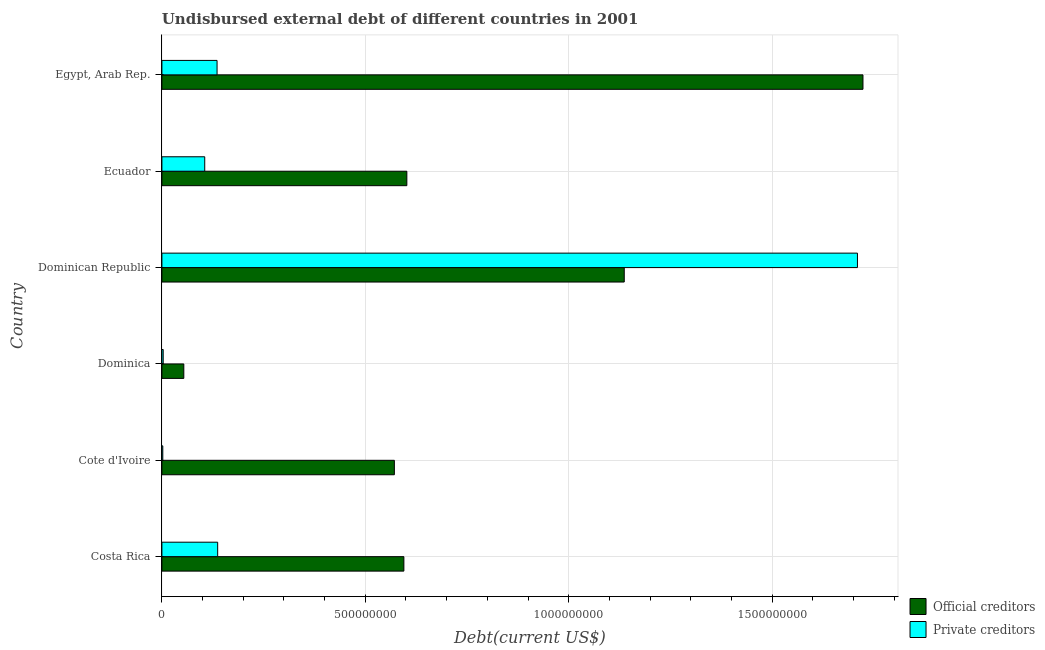Are the number of bars per tick equal to the number of legend labels?
Your answer should be very brief. Yes. Are the number of bars on each tick of the Y-axis equal?
Your answer should be very brief. Yes. How many bars are there on the 3rd tick from the top?
Your response must be concise. 2. How many bars are there on the 4th tick from the bottom?
Offer a very short reply. 2. What is the label of the 2nd group of bars from the top?
Provide a succinct answer. Ecuador. In how many cases, is the number of bars for a given country not equal to the number of legend labels?
Provide a short and direct response. 0. What is the undisbursed external debt of private creditors in Dominican Republic?
Offer a very short reply. 1.71e+09. Across all countries, what is the maximum undisbursed external debt of official creditors?
Your response must be concise. 1.72e+09. Across all countries, what is the minimum undisbursed external debt of official creditors?
Offer a terse response. 5.38e+07. In which country was the undisbursed external debt of private creditors maximum?
Keep it short and to the point. Dominican Republic. In which country was the undisbursed external debt of private creditors minimum?
Your response must be concise. Cote d'Ivoire. What is the total undisbursed external debt of private creditors in the graph?
Provide a short and direct response. 2.09e+09. What is the difference between the undisbursed external debt of private creditors in Cote d'Ivoire and that in Dominica?
Your answer should be very brief. -1.01e+06. What is the difference between the undisbursed external debt of private creditors in Egypt, Arab Rep. and the undisbursed external debt of official creditors in Dominica?
Provide a succinct answer. 8.17e+07. What is the average undisbursed external debt of official creditors per country?
Keep it short and to the point. 7.80e+08. What is the difference between the undisbursed external debt of private creditors and undisbursed external debt of official creditors in Cote d'Ivoire?
Offer a terse response. -5.69e+08. What is the ratio of the undisbursed external debt of private creditors in Costa Rica to that in Cote d'Ivoire?
Your answer should be very brief. 62.47. Is the difference between the undisbursed external debt of private creditors in Costa Rica and Dominican Republic greater than the difference between the undisbursed external debt of official creditors in Costa Rica and Dominican Republic?
Offer a very short reply. No. What is the difference between the highest and the second highest undisbursed external debt of private creditors?
Your response must be concise. 1.57e+09. What is the difference between the highest and the lowest undisbursed external debt of official creditors?
Provide a succinct answer. 1.67e+09. What does the 2nd bar from the top in Egypt, Arab Rep. represents?
Ensure brevity in your answer.  Official creditors. What does the 1st bar from the bottom in Egypt, Arab Rep. represents?
Give a very brief answer. Official creditors. Where does the legend appear in the graph?
Provide a short and direct response. Bottom right. What is the title of the graph?
Offer a very short reply. Undisbursed external debt of different countries in 2001. What is the label or title of the X-axis?
Keep it short and to the point. Debt(current US$). What is the Debt(current US$) in Official creditors in Costa Rica?
Make the answer very short. 5.95e+08. What is the Debt(current US$) in Private creditors in Costa Rica?
Make the answer very short. 1.37e+08. What is the Debt(current US$) in Official creditors in Cote d'Ivoire?
Your answer should be very brief. 5.71e+08. What is the Debt(current US$) in Private creditors in Cote d'Ivoire?
Your response must be concise. 2.20e+06. What is the Debt(current US$) of Official creditors in Dominica?
Ensure brevity in your answer.  5.38e+07. What is the Debt(current US$) of Private creditors in Dominica?
Ensure brevity in your answer.  3.20e+06. What is the Debt(current US$) in Official creditors in Dominican Republic?
Offer a terse response. 1.14e+09. What is the Debt(current US$) in Private creditors in Dominican Republic?
Offer a terse response. 1.71e+09. What is the Debt(current US$) of Official creditors in Ecuador?
Make the answer very short. 6.02e+08. What is the Debt(current US$) of Private creditors in Ecuador?
Keep it short and to the point. 1.05e+08. What is the Debt(current US$) in Official creditors in Egypt, Arab Rep.?
Ensure brevity in your answer.  1.72e+09. What is the Debt(current US$) of Private creditors in Egypt, Arab Rep.?
Your response must be concise. 1.36e+08. Across all countries, what is the maximum Debt(current US$) of Official creditors?
Keep it short and to the point. 1.72e+09. Across all countries, what is the maximum Debt(current US$) in Private creditors?
Give a very brief answer. 1.71e+09. Across all countries, what is the minimum Debt(current US$) of Official creditors?
Make the answer very short. 5.38e+07. Across all countries, what is the minimum Debt(current US$) of Private creditors?
Give a very brief answer. 2.20e+06. What is the total Debt(current US$) of Official creditors in the graph?
Your response must be concise. 4.68e+09. What is the total Debt(current US$) of Private creditors in the graph?
Your answer should be very brief. 2.09e+09. What is the difference between the Debt(current US$) of Official creditors in Costa Rica and that in Cote d'Ivoire?
Give a very brief answer. 2.34e+07. What is the difference between the Debt(current US$) of Private creditors in Costa Rica and that in Cote d'Ivoire?
Ensure brevity in your answer.  1.35e+08. What is the difference between the Debt(current US$) in Official creditors in Costa Rica and that in Dominica?
Keep it short and to the point. 5.41e+08. What is the difference between the Debt(current US$) of Private creditors in Costa Rica and that in Dominica?
Offer a terse response. 1.34e+08. What is the difference between the Debt(current US$) of Official creditors in Costa Rica and that in Dominican Republic?
Ensure brevity in your answer.  -5.42e+08. What is the difference between the Debt(current US$) of Private creditors in Costa Rica and that in Dominican Republic?
Your answer should be compact. -1.57e+09. What is the difference between the Debt(current US$) in Official creditors in Costa Rica and that in Ecuador?
Offer a terse response. -7.28e+06. What is the difference between the Debt(current US$) of Private creditors in Costa Rica and that in Ecuador?
Provide a short and direct response. 3.18e+07. What is the difference between the Debt(current US$) in Official creditors in Costa Rica and that in Egypt, Arab Rep.?
Ensure brevity in your answer.  -1.13e+09. What is the difference between the Debt(current US$) of Private creditors in Costa Rica and that in Egypt, Arab Rep.?
Your answer should be very brief. 1.53e+06. What is the difference between the Debt(current US$) in Official creditors in Cote d'Ivoire and that in Dominica?
Provide a succinct answer. 5.18e+08. What is the difference between the Debt(current US$) of Private creditors in Cote d'Ivoire and that in Dominica?
Offer a very short reply. -1.01e+06. What is the difference between the Debt(current US$) in Official creditors in Cote d'Ivoire and that in Dominican Republic?
Make the answer very short. -5.65e+08. What is the difference between the Debt(current US$) in Private creditors in Cote d'Ivoire and that in Dominican Republic?
Give a very brief answer. -1.71e+09. What is the difference between the Debt(current US$) of Official creditors in Cote d'Ivoire and that in Ecuador?
Your answer should be very brief. -3.07e+07. What is the difference between the Debt(current US$) in Private creditors in Cote d'Ivoire and that in Ecuador?
Ensure brevity in your answer.  -1.03e+08. What is the difference between the Debt(current US$) of Official creditors in Cote d'Ivoire and that in Egypt, Arab Rep.?
Provide a succinct answer. -1.15e+09. What is the difference between the Debt(current US$) of Private creditors in Cote d'Ivoire and that in Egypt, Arab Rep.?
Your answer should be compact. -1.33e+08. What is the difference between the Debt(current US$) of Official creditors in Dominica and that in Dominican Republic?
Your response must be concise. -1.08e+09. What is the difference between the Debt(current US$) in Private creditors in Dominica and that in Dominican Republic?
Your answer should be compact. -1.71e+09. What is the difference between the Debt(current US$) of Official creditors in Dominica and that in Ecuador?
Your answer should be compact. -5.48e+08. What is the difference between the Debt(current US$) in Private creditors in Dominica and that in Ecuador?
Your response must be concise. -1.02e+08. What is the difference between the Debt(current US$) in Official creditors in Dominica and that in Egypt, Arab Rep.?
Provide a short and direct response. -1.67e+09. What is the difference between the Debt(current US$) of Private creditors in Dominica and that in Egypt, Arab Rep.?
Your answer should be compact. -1.32e+08. What is the difference between the Debt(current US$) in Official creditors in Dominican Republic and that in Ecuador?
Your answer should be compact. 5.34e+08. What is the difference between the Debt(current US$) of Private creditors in Dominican Republic and that in Ecuador?
Your response must be concise. 1.60e+09. What is the difference between the Debt(current US$) in Official creditors in Dominican Republic and that in Egypt, Arab Rep.?
Your answer should be very brief. -5.87e+08. What is the difference between the Debt(current US$) of Private creditors in Dominican Republic and that in Egypt, Arab Rep.?
Keep it short and to the point. 1.57e+09. What is the difference between the Debt(current US$) in Official creditors in Ecuador and that in Egypt, Arab Rep.?
Your answer should be compact. -1.12e+09. What is the difference between the Debt(current US$) of Private creditors in Ecuador and that in Egypt, Arab Rep.?
Your answer should be compact. -3.03e+07. What is the difference between the Debt(current US$) of Official creditors in Costa Rica and the Debt(current US$) of Private creditors in Cote d'Ivoire?
Keep it short and to the point. 5.93e+08. What is the difference between the Debt(current US$) of Official creditors in Costa Rica and the Debt(current US$) of Private creditors in Dominica?
Provide a short and direct response. 5.92e+08. What is the difference between the Debt(current US$) in Official creditors in Costa Rica and the Debt(current US$) in Private creditors in Dominican Republic?
Make the answer very short. -1.11e+09. What is the difference between the Debt(current US$) of Official creditors in Costa Rica and the Debt(current US$) of Private creditors in Ecuador?
Offer a terse response. 4.90e+08. What is the difference between the Debt(current US$) of Official creditors in Costa Rica and the Debt(current US$) of Private creditors in Egypt, Arab Rep.?
Keep it short and to the point. 4.59e+08. What is the difference between the Debt(current US$) of Official creditors in Cote d'Ivoire and the Debt(current US$) of Private creditors in Dominica?
Make the answer very short. 5.68e+08. What is the difference between the Debt(current US$) of Official creditors in Cote d'Ivoire and the Debt(current US$) of Private creditors in Dominican Republic?
Your answer should be very brief. -1.14e+09. What is the difference between the Debt(current US$) in Official creditors in Cote d'Ivoire and the Debt(current US$) in Private creditors in Ecuador?
Your answer should be very brief. 4.66e+08. What is the difference between the Debt(current US$) in Official creditors in Cote d'Ivoire and the Debt(current US$) in Private creditors in Egypt, Arab Rep.?
Keep it short and to the point. 4.36e+08. What is the difference between the Debt(current US$) in Official creditors in Dominica and the Debt(current US$) in Private creditors in Dominican Republic?
Provide a short and direct response. -1.66e+09. What is the difference between the Debt(current US$) in Official creditors in Dominica and the Debt(current US$) in Private creditors in Ecuador?
Make the answer very short. -5.15e+07. What is the difference between the Debt(current US$) in Official creditors in Dominica and the Debt(current US$) in Private creditors in Egypt, Arab Rep.?
Offer a very short reply. -8.17e+07. What is the difference between the Debt(current US$) in Official creditors in Dominican Republic and the Debt(current US$) in Private creditors in Ecuador?
Your response must be concise. 1.03e+09. What is the difference between the Debt(current US$) in Official creditors in Dominican Republic and the Debt(current US$) in Private creditors in Egypt, Arab Rep.?
Give a very brief answer. 1.00e+09. What is the difference between the Debt(current US$) of Official creditors in Ecuador and the Debt(current US$) of Private creditors in Egypt, Arab Rep.?
Make the answer very short. 4.67e+08. What is the average Debt(current US$) in Official creditors per country?
Offer a terse response. 7.80e+08. What is the average Debt(current US$) in Private creditors per country?
Give a very brief answer. 3.49e+08. What is the difference between the Debt(current US$) of Official creditors and Debt(current US$) of Private creditors in Costa Rica?
Offer a terse response. 4.58e+08. What is the difference between the Debt(current US$) in Official creditors and Debt(current US$) in Private creditors in Cote d'Ivoire?
Make the answer very short. 5.69e+08. What is the difference between the Debt(current US$) in Official creditors and Debt(current US$) in Private creditors in Dominica?
Ensure brevity in your answer.  5.06e+07. What is the difference between the Debt(current US$) of Official creditors and Debt(current US$) of Private creditors in Dominican Republic?
Your answer should be very brief. -5.73e+08. What is the difference between the Debt(current US$) in Official creditors and Debt(current US$) in Private creditors in Ecuador?
Provide a short and direct response. 4.97e+08. What is the difference between the Debt(current US$) of Official creditors and Debt(current US$) of Private creditors in Egypt, Arab Rep.?
Ensure brevity in your answer.  1.59e+09. What is the ratio of the Debt(current US$) of Official creditors in Costa Rica to that in Cote d'Ivoire?
Offer a terse response. 1.04. What is the ratio of the Debt(current US$) of Private creditors in Costa Rica to that in Cote d'Ivoire?
Provide a succinct answer. 62.47. What is the ratio of the Debt(current US$) in Official creditors in Costa Rica to that in Dominica?
Make the answer very short. 11.05. What is the ratio of the Debt(current US$) in Private creditors in Costa Rica to that in Dominica?
Your response must be concise. 42.78. What is the ratio of the Debt(current US$) in Official creditors in Costa Rica to that in Dominican Republic?
Give a very brief answer. 0.52. What is the ratio of the Debt(current US$) in Private creditors in Costa Rica to that in Dominican Republic?
Make the answer very short. 0.08. What is the ratio of the Debt(current US$) in Official creditors in Costa Rica to that in Ecuador?
Keep it short and to the point. 0.99. What is the ratio of the Debt(current US$) in Private creditors in Costa Rica to that in Ecuador?
Your answer should be very brief. 1.3. What is the ratio of the Debt(current US$) in Official creditors in Costa Rica to that in Egypt, Arab Rep.?
Ensure brevity in your answer.  0.35. What is the ratio of the Debt(current US$) in Private creditors in Costa Rica to that in Egypt, Arab Rep.?
Offer a very short reply. 1.01. What is the ratio of the Debt(current US$) of Official creditors in Cote d'Ivoire to that in Dominica?
Keep it short and to the point. 10.61. What is the ratio of the Debt(current US$) of Private creditors in Cote d'Ivoire to that in Dominica?
Your answer should be compact. 0.68. What is the ratio of the Debt(current US$) of Official creditors in Cote d'Ivoire to that in Dominican Republic?
Offer a very short reply. 0.5. What is the ratio of the Debt(current US$) of Private creditors in Cote d'Ivoire to that in Dominican Republic?
Make the answer very short. 0. What is the ratio of the Debt(current US$) of Official creditors in Cote d'Ivoire to that in Ecuador?
Provide a short and direct response. 0.95. What is the ratio of the Debt(current US$) of Private creditors in Cote d'Ivoire to that in Ecuador?
Make the answer very short. 0.02. What is the ratio of the Debt(current US$) of Official creditors in Cote d'Ivoire to that in Egypt, Arab Rep.?
Offer a very short reply. 0.33. What is the ratio of the Debt(current US$) of Private creditors in Cote d'Ivoire to that in Egypt, Arab Rep.?
Your response must be concise. 0.02. What is the ratio of the Debt(current US$) of Official creditors in Dominica to that in Dominican Republic?
Make the answer very short. 0.05. What is the ratio of the Debt(current US$) of Private creditors in Dominica to that in Dominican Republic?
Your answer should be compact. 0. What is the ratio of the Debt(current US$) in Official creditors in Dominica to that in Ecuador?
Your answer should be compact. 0.09. What is the ratio of the Debt(current US$) of Private creditors in Dominica to that in Ecuador?
Ensure brevity in your answer.  0.03. What is the ratio of the Debt(current US$) of Official creditors in Dominica to that in Egypt, Arab Rep.?
Provide a short and direct response. 0.03. What is the ratio of the Debt(current US$) of Private creditors in Dominica to that in Egypt, Arab Rep.?
Your response must be concise. 0.02. What is the ratio of the Debt(current US$) of Official creditors in Dominican Republic to that in Ecuador?
Offer a very short reply. 1.89. What is the ratio of the Debt(current US$) in Private creditors in Dominican Republic to that in Ecuador?
Your answer should be very brief. 16.24. What is the ratio of the Debt(current US$) in Official creditors in Dominican Republic to that in Egypt, Arab Rep.?
Give a very brief answer. 0.66. What is the ratio of the Debt(current US$) in Private creditors in Dominican Republic to that in Egypt, Arab Rep.?
Your answer should be very brief. 12.61. What is the ratio of the Debt(current US$) in Official creditors in Ecuador to that in Egypt, Arab Rep.?
Offer a terse response. 0.35. What is the ratio of the Debt(current US$) in Private creditors in Ecuador to that in Egypt, Arab Rep.?
Offer a terse response. 0.78. What is the difference between the highest and the second highest Debt(current US$) in Official creditors?
Provide a short and direct response. 5.87e+08. What is the difference between the highest and the second highest Debt(current US$) of Private creditors?
Offer a terse response. 1.57e+09. What is the difference between the highest and the lowest Debt(current US$) of Official creditors?
Your answer should be compact. 1.67e+09. What is the difference between the highest and the lowest Debt(current US$) of Private creditors?
Your answer should be compact. 1.71e+09. 